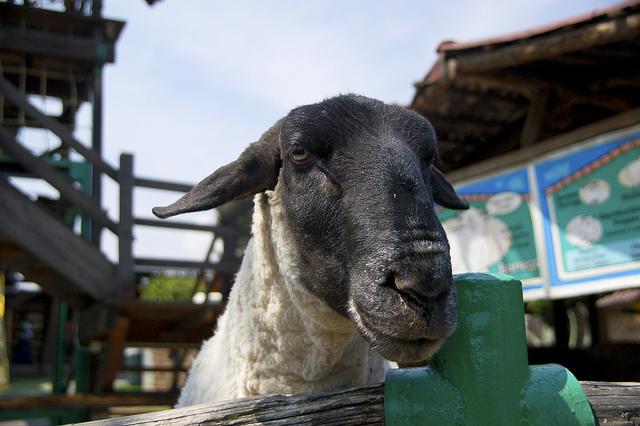What is this animal?
Concise answer only. Sheep. Can you ride this animal?
Write a very short answer. No. What animal is in the picture?
Answer briefly. Sheep. How many animals?
Quick response, please. 1. 